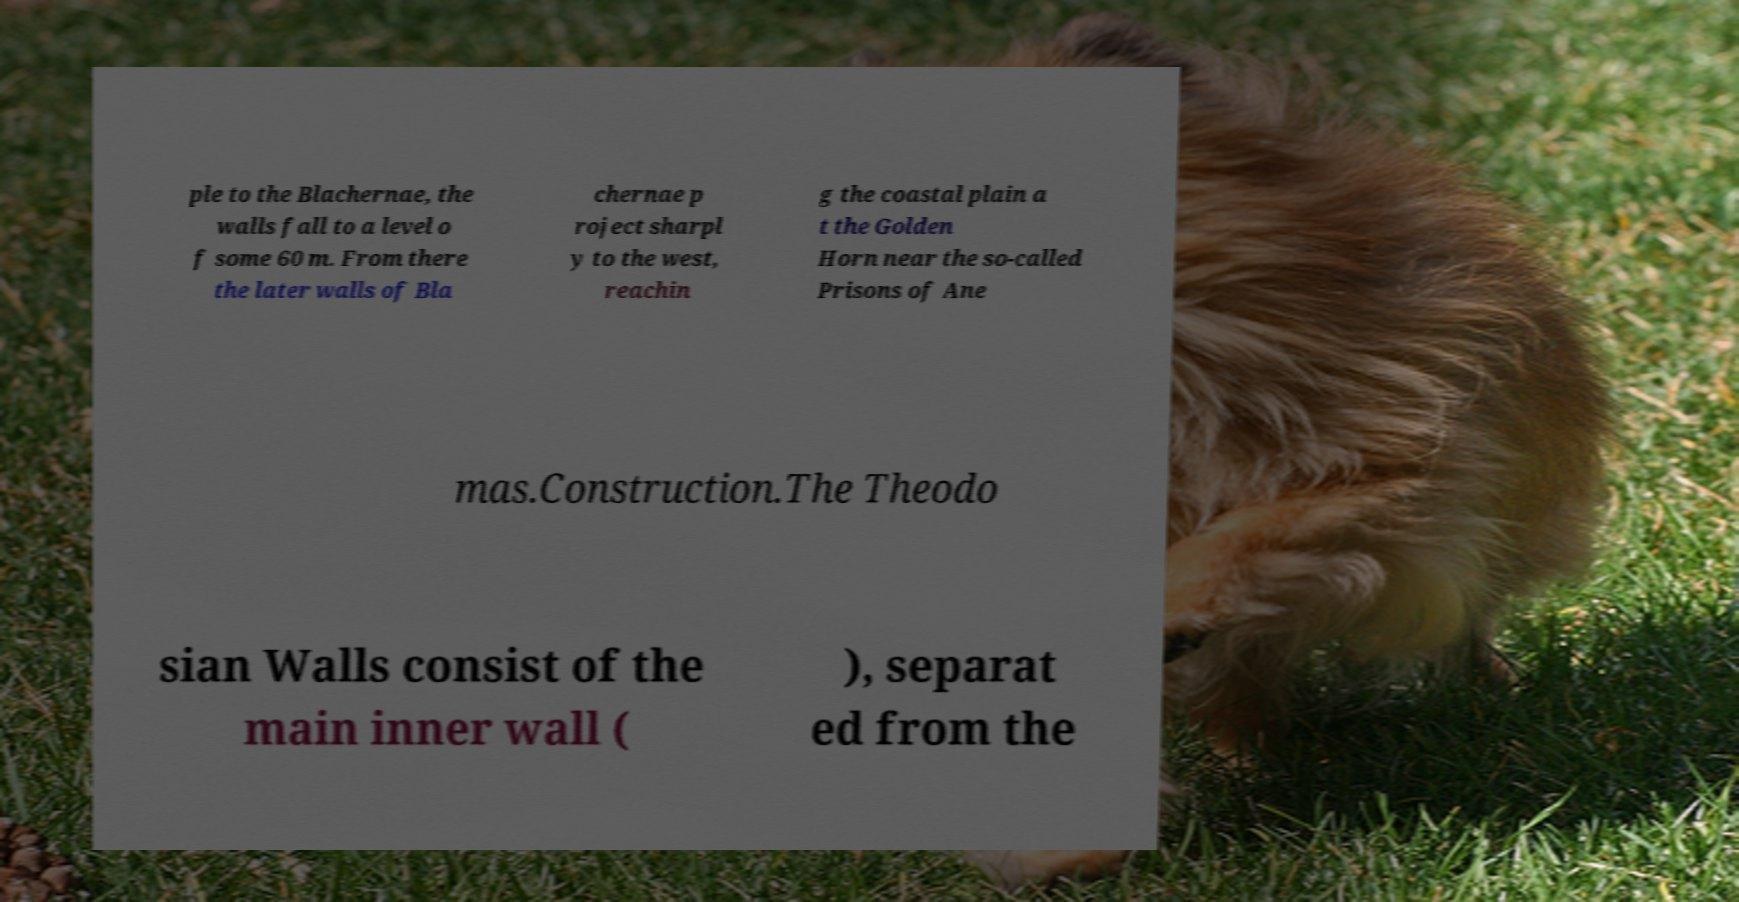What messages or text are displayed in this image? I need them in a readable, typed format. ple to the Blachernae, the walls fall to a level o f some 60 m. From there the later walls of Bla chernae p roject sharpl y to the west, reachin g the coastal plain a t the Golden Horn near the so-called Prisons of Ane mas.Construction.The Theodo sian Walls consist of the main inner wall ( ), separat ed from the 